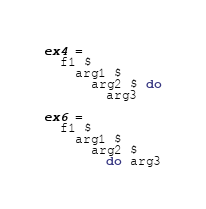Convert code to text. <code><loc_0><loc_0><loc_500><loc_500><_Haskell_>ex4 =
  f1 $
    arg1 $
      arg2 $ do
        arg3

ex6 =
  f1 $
    arg1 $
      arg2 $
        do arg3
</code> 